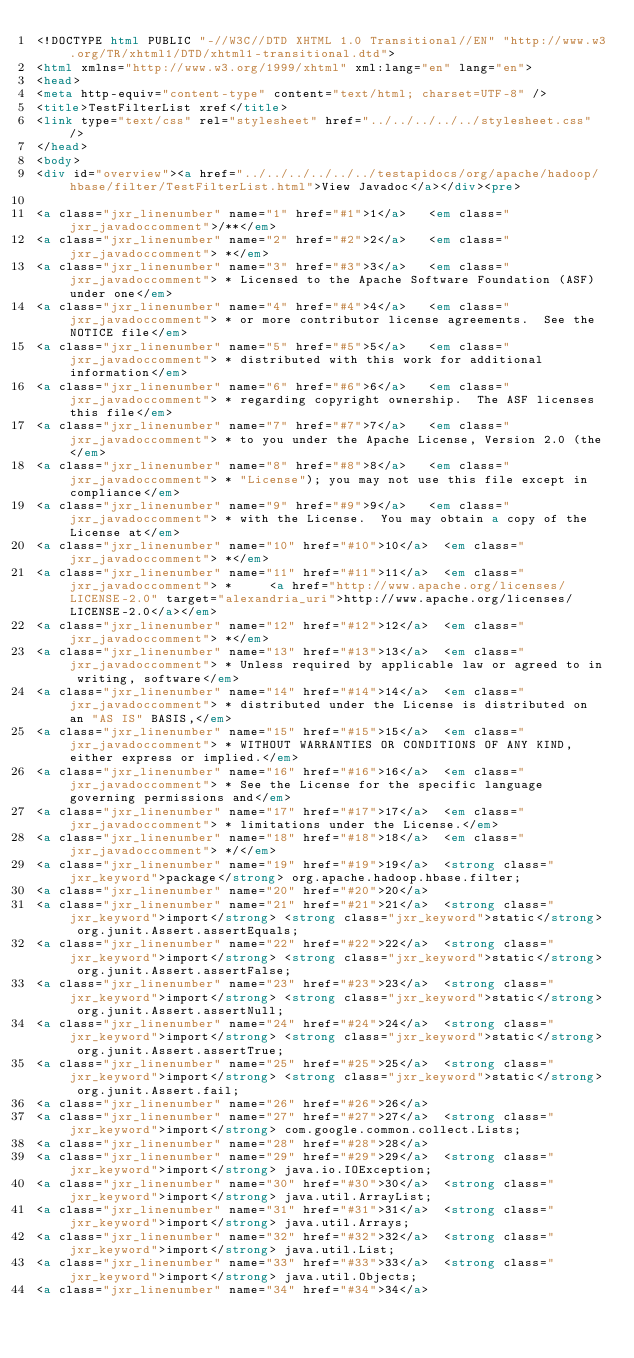Convert code to text. <code><loc_0><loc_0><loc_500><loc_500><_HTML_><!DOCTYPE html PUBLIC "-//W3C//DTD XHTML 1.0 Transitional//EN" "http://www.w3.org/TR/xhtml1/DTD/xhtml1-transitional.dtd">
<html xmlns="http://www.w3.org/1999/xhtml" xml:lang="en" lang="en">
<head>
<meta http-equiv="content-type" content="text/html; charset=UTF-8" />
<title>TestFilterList xref</title>
<link type="text/css" rel="stylesheet" href="../../../../../stylesheet.css" />
</head>
<body>
<div id="overview"><a href="../../../../../../testapidocs/org/apache/hadoop/hbase/filter/TestFilterList.html">View Javadoc</a></div><pre>

<a class="jxr_linenumber" name="1" href="#1">1</a>   <em class="jxr_javadoccomment">/**</em>
<a class="jxr_linenumber" name="2" href="#2">2</a>   <em class="jxr_javadoccomment"> *</em>
<a class="jxr_linenumber" name="3" href="#3">3</a>   <em class="jxr_javadoccomment"> * Licensed to the Apache Software Foundation (ASF) under one</em>
<a class="jxr_linenumber" name="4" href="#4">4</a>   <em class="jxr_javadoccomment"> * or more contributor license agreements.  See the NOTICE file</em>
<a class="jxr_linenumber" name="5" href="#5">5</a>   <em class="jxr_javadoccomment"> * distributed with this work for additional information</em>
<a class="jxr_linenumber" name="6" href="#6">6</a>   <em class="jxr_javadoccomment"> * regarding copyright ownership.  The ASF licenses this file</em>
<a class="jxr_linenumber" name="7" href="#7">7</a>   <em class="jxr_javadoccomment"> * to you under the Apache License, Version 2.0 (the</em>
<a class="jxr_linenumber" name="8" href="#8">8</a>   <em class="jxr_javadoccomment"> * "License"); you may not use this file except in compliance</em>
<a class="jxr_linenumber" name="9" href="#9">9</a>   <em class="jxr_javadoccomment"> * with the License.  You may obtain a copy of the License at</em>
<a class="jxr_linenumber" name="10" href="#10">10</a>  <em class="jxr_javadoccomment"> *</em>
<a class="jxr_linenumber" name="11" href="#11">11</a>  <em class="jxr_javadoccomment"> *     <a href="http://www.apache.org/licenses/LICENSE-2.0" target="alexandria_uri">http://www.apache.org/licenses/LICENSE-2.0</a></em>
<a class="jxr_linenumber" name="12" href="#12">12</a>  <em class="jxr_javadoccomment"> *</em>
<a class="jxr_linenumber" name="13" href="#13">13</a>  <em class="jxr_javadoccomment"> * Unless required by applicable law or agreed to in writing, software</em>
<a class="jxr_linenumber" name="14" href="#14">14</a>  <em class="jxr_javadoccomment"> * distributed under the License is distributed on an "AS IS" BASIS,</em>
<a class="jxr_linenumber" name="15" href="#15">15</a>  <em class="jxr_javadoccomment"> * WITHOUT WARRANTIES OR CONDITIONS OF ANY KIND, either express or implied.</em>
<a class="jxr_linenumber" name="16" href="#16">16</a>  <em class="jxr_javadoccomment"> * See the License for the specific language governing permissions and</em>
<a class="jxr_linenumber" name="17" href="#17">17</a>  <em class="jxr_javadoccomment"> * limitations under the License.</em>
<a class="jxr_linenumber" name="18" href="#18">18</a>  <em class="jxr_javadoccomment"> */</em>
<a class="jxr_linenumber" name="19" href="#19">19</a>  <strong class="jxr_keyword">package</strong> org.apache.hadoop.hbase.filter;
<a class="jxr_linenumber" name="20" href="#20">20</a>  
<a class="jxr_linenumber" name="21" href="#21">21</a>  <strong class="jxr_keyword">import</strong> <strong class="jxr_keyword">static</strong> org.junit.Assert.assertEquals;
<a class="jxr_linenumber" name="22" href="#22">22</a>  <strong class="jxr_keyword">import</strong> <strong class="jxr_keyword">static</strong> org.junit.Assert.assertFalse;
<a class="jxr_linenumber" name="23" href="#23">23</a>  <strong class="jxr_keyword">import</strong> <strong class="jxr_keyword">static</strong> org.junit.Assert.assertNull;
<a class="jxr_linenumber" name="24" href="#24">24</a>  <strong class="jxr_keyword">import</strong> <strong class="jxr_keyword">static</strong> org.junit.Assert.assertTrue;
<a class="jxr_linenumber" name="25" href="#25">25</a>  <strong class="jxr_keyword">import</strong> <strong class="jxr_keyword">static</strong> org.junit.Assert.fail;
<a class="jxr_linenumber" name="26" href="#26">26</a>  
<a class="jxr_linenumber" name="27" href="#27">27</a>  <strong class="jxr_keyword">import</strong> com.google.common.collect.Lists;
<a class="jxr_linenumber" name="28" href="#28">28</a>  
<a class="jxr_linenumber" name="29" href="#29">29</a>  <strong class="jxr_keyword">import</strong> java.io.IOException;
<a class="jxr_linenumber" name="30" href="#30">30</a>  <strong class="jxr_keyword">import</strong> java.util.ArrayList;
<a class="jxr_linenumber" name="31" href="#31">31</a>  <strong class="jxr_keyword">import</strong> java.util.Arrays;
<a class="jxr_linenumber" name="32" href="#32">32</a>  <strong class="jxr_keyword">import</strong> java.util.List;
<a class="jxr_linenumber" name="33" href="#33">33</a>  <strong class="jxr_keyword">import</strong> java.util.Objects;
<a class="jxr_linenumber" name="34" href="#34">34</a>  </code> 